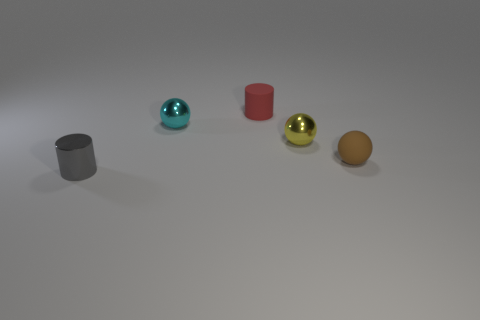How many other things are the same shape as the tiny brown rubber thing?
Provide a short and direct response. 2. What number of spheres are either brown things or tiny cyan objects?
Offer a terse response. 2. Are there any tiny spheres to the right of the tiny cylinder that is to the right of the small gray metallic object in front of the small red matte cylinder?
Give a very brief answer. Yes. What is the color of the other metal thing that is the same shape as the yellow metal thing?
Your answer should be compact. Cyan. What number of brown things are small matte spheres or big rubber blocks?
Keep it short and to the point. 1. The small sphere left of the small cylinder behind the gray cylinder is made of what material?
Your answer should be very brief. Metal. Is the small red matte object the same shape as the tiny gray object?
Your answer should be very brief. Yes. The rubber cylinder that is the same size as the gray metallic thing is what color?
Offer a very short reply. Red. Are there any other tiny matte cylinders that have the same color as the tiny matte cylinder?
Give a very brief answer. No. Is there a brown metallic thing?
Your response must be concise. No. 